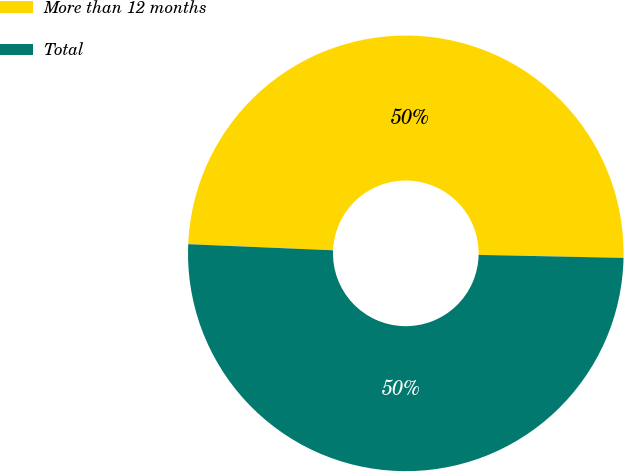Convert chart. <chart><loc_0><loc_0><loc_500><loc_500><pie_chart><fcel>More than 12 months<fcel>Total<nl><fcel>49.66%<fcel>50.34%<nl></chart> 